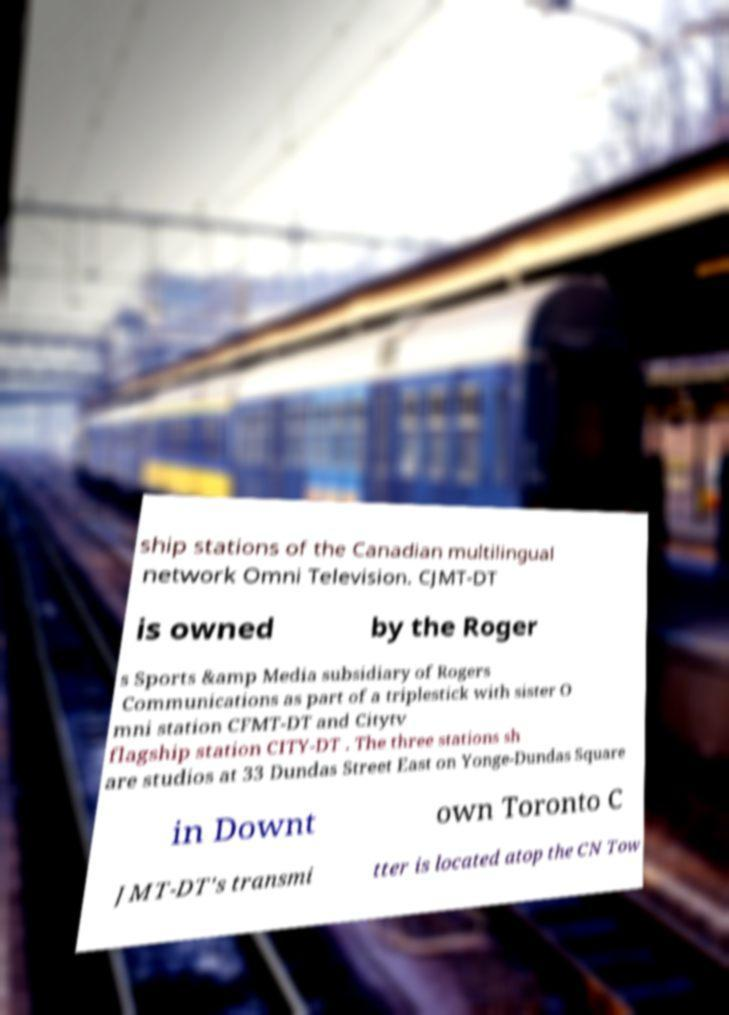There's text embedded in this image that I need extracted. Can you transcribe it verbatim? ship stations of the Canadian multilingual network Omni Television. CJMT-DT is owned by the Roger s Sports &amp Media subsidiary of Rogers Communications as part of a triplestick with sister O mni station CFMT-DT and Citytv flagship station CITY-DT . The three stations sh are studios at 33 Dundas Street East on Yonge-Dundas Square in Downt own Toronto C JMT-DT's transmi tter is located atop the CN Tow 